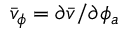Convert formula to latex. <formula><loc_0><loc_0><loc_500><loc_500>\bar { v } _ { \phi } = \partial \bar { v } / \partial \phi _ { a }</formula> 